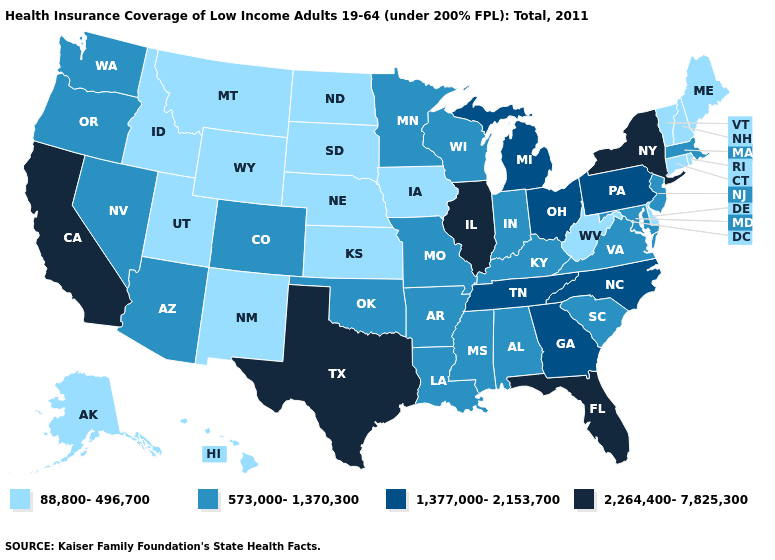Does Missouri have the same value as Nevada?
Concise answer only. Yes. What is the value of Tennessee?
Concise answer only. 1,377,000-2,153,700. Does the first symbol in the legend represent the smallest category?
Write a very short answer. Yes. Does Texas have the highest value in the South?
Write a very short answer. Yes. What is the value of Idaho?
Keep it brief. 88,800-496,700. Does Colorado have the same value as Arizona?
Answer briefly. Yes. What is the highest value in the Northeast ?
Short answer required. 2,264,400-7,825,300. Does the map have missing data?
Be succinct. No. Among the states that border Pennsylvania , which have the highest value?
Be succinct. New York. Among the states that border West Virginia , which have the highest value?
Quick response, please. Ohio, Pennsylvania. Name the states that have a value in the range 88,800-496,700?
Keep it brief. Alaska, Connecticut, Delaware, Hawaii, Idaho, Iowa, Kansas, Maine, Montana, Nebraska, New Hampshire, New Mexico, North Dakota, Rhode Island, South Dakota, Utah, Vermont, West Virginia, Wyoming. Name the states that have a value in the range 88,800-496,700?
Keep it brief. Alaska, Connecticut, Delaware, Hawaii, Idaho, Iowa, Kansas, Maine, Montana, Nebraska, New Hampshire, New Mexico, North Dakota, Rhode Island, South Dakota, Utah, Vermont, West Virginia, Wyoming. Among the states that border Arizona , which have the lowest value?
Give a very brief answer. New Mexico, Utah. Is the legend a continuous bar?
Answer briefly. No. What is the highest value in the USA?
Write a very short answer. 2,264,400-7,825,300. 